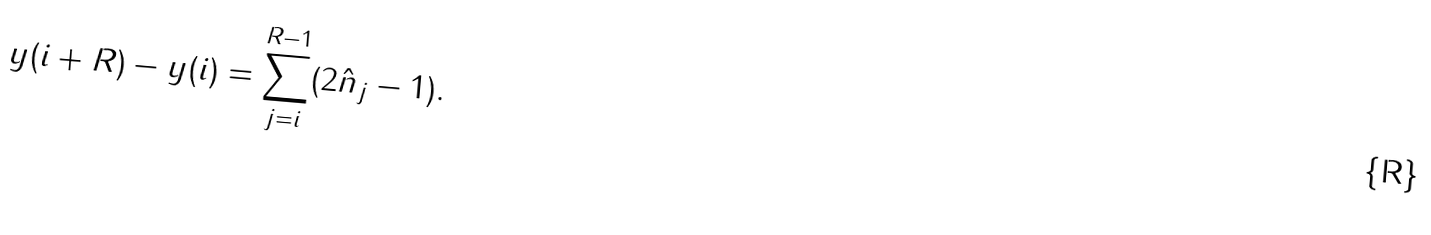Convert formula to latex. <formula><loc_0><loc_0><loc_500><loc_500>y ( i + R ) - y ( i ) = \sum _ { j = i } ^ { R - 1 } ( 2 \hat { n } _ { j } - 1 ) .</formula> 